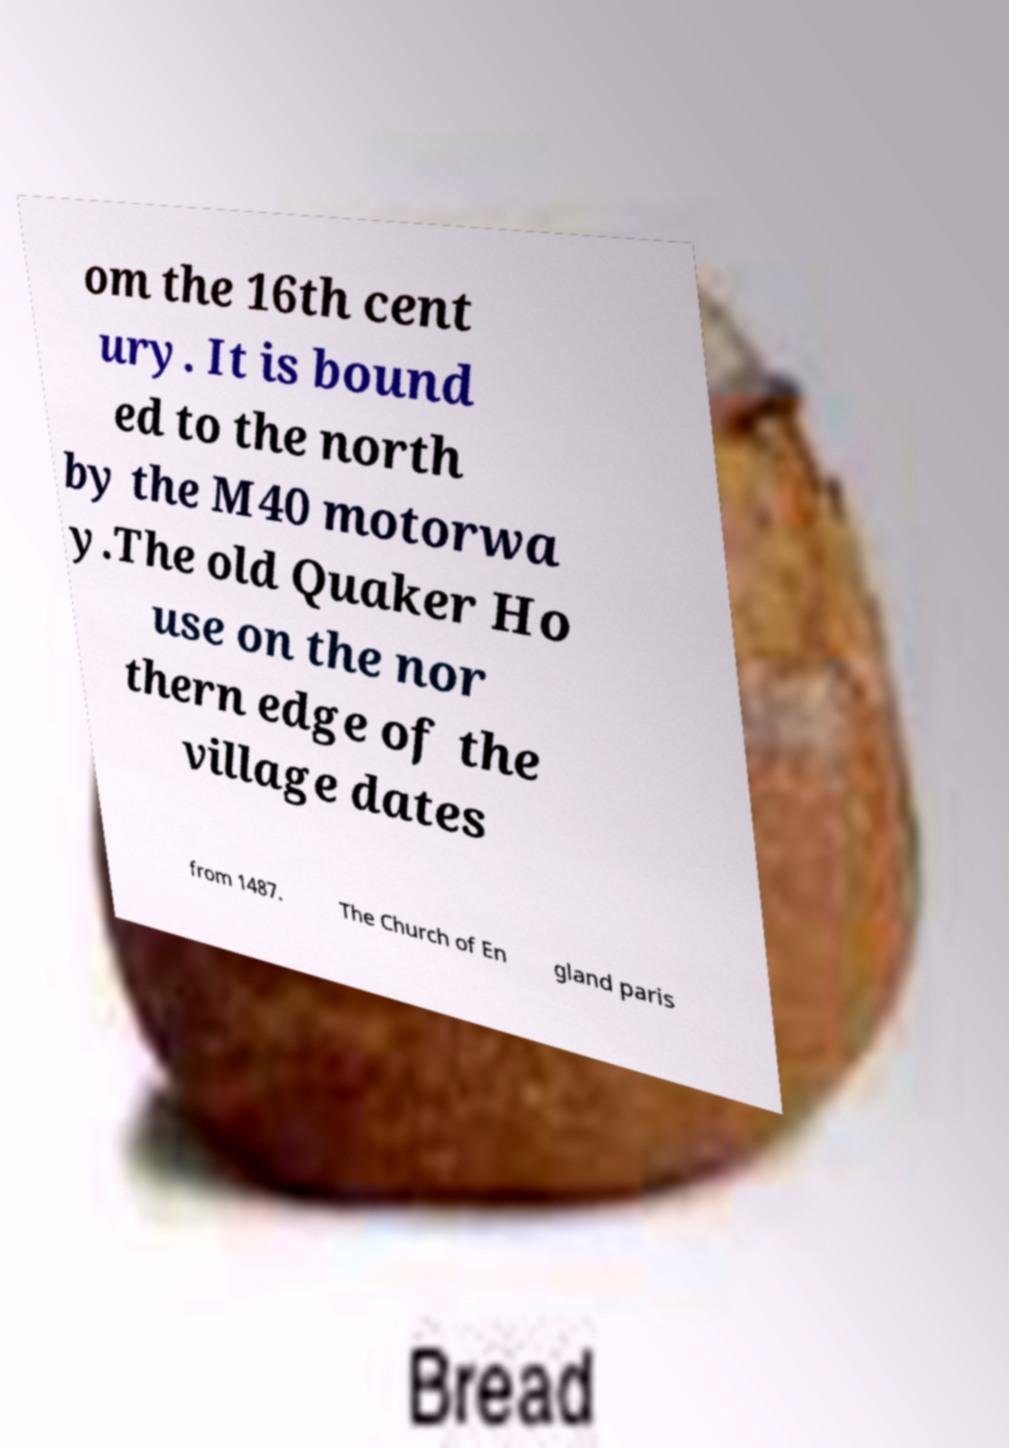Please read and relay the text visible in this image. What does it say? om the 16th cent ury. It is bound ed to the north by the M40 motorwa y.The old Quaker Ho use on the nor thern edge of the village dates from 1487. The Church of En gland paris 